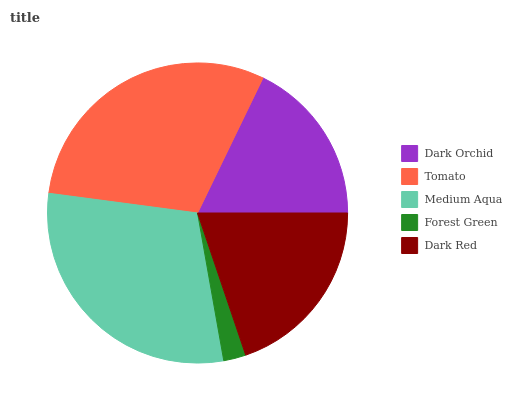Is Forest Green the minimum?
Answer yes or no. Yes. Is Tomato the maximum?
Answer yes or no. Yes. Is Medium Aqua the minimum?
Answer yes or no. No. Is Medium Aqua the maximum?
Answer yes or no. No. Is Tomato greater than Medium Aqua?
Answer yes or no. Yes. Is Medium Aqua less than Tomato?
Answer yes or no. Yes. Is Medium Aqua greater than Tomato?
Answer yes or no. No. Is Tomato less than Medium Aqua?
Answer yes or no. No. Is Dark Red the high median?
Answer yes or no. Yes. Is Dark Red the low median?
Answer yes or no. Yes. Is Dark Orchid the high median?
Answer yes or no. No. Is Dark Orchid the low median?
Answer yes or no. No. 